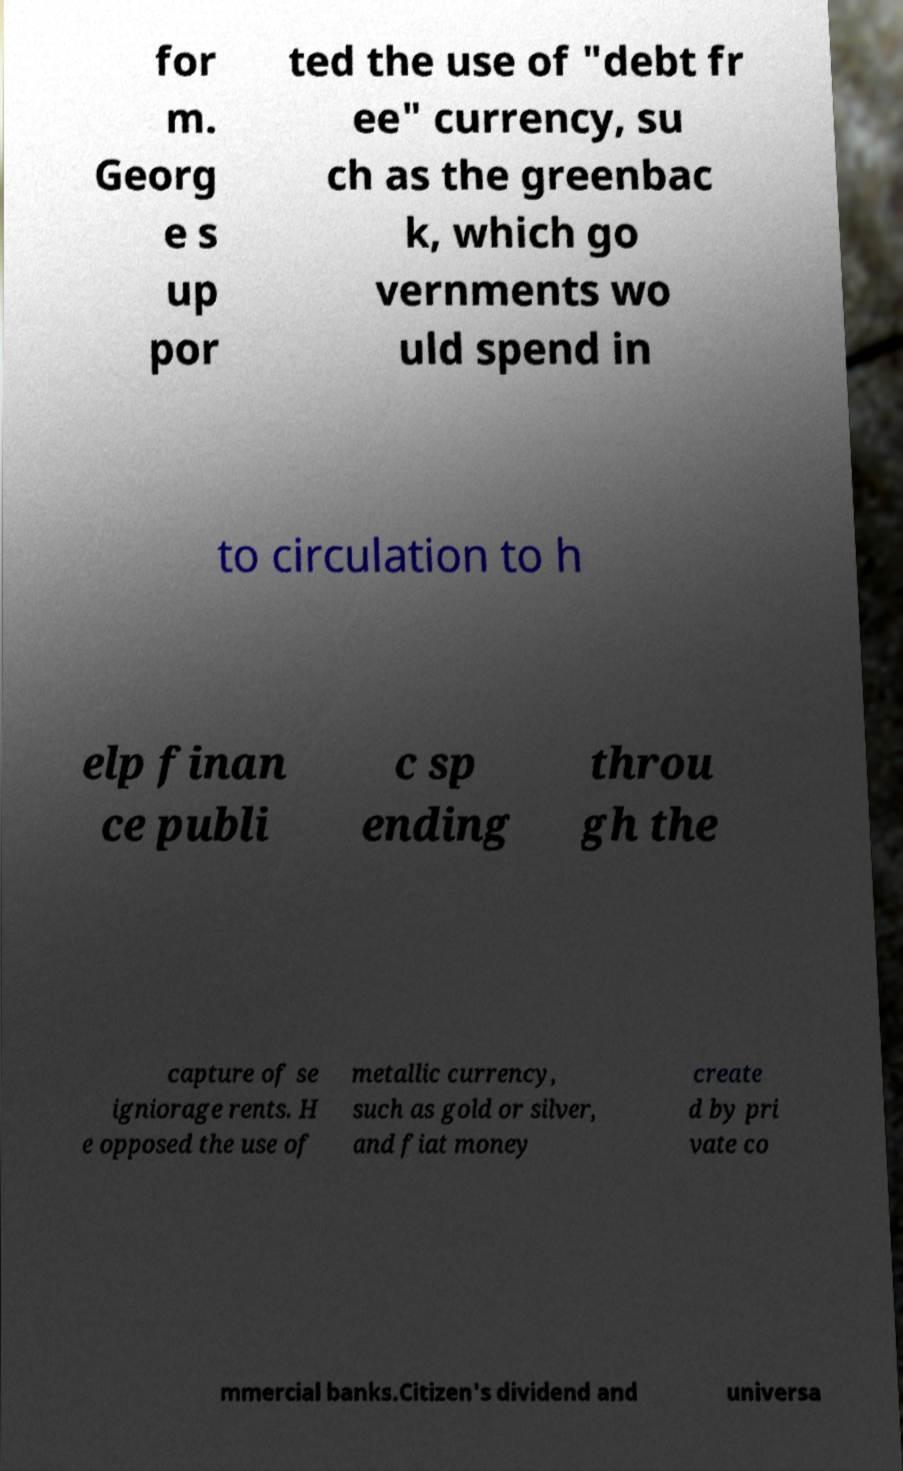There's text embedded in this image that I need extracted. Can you transcribe it verbatim? for m. Georg e s up por ted the use of "debt fr ee" currency, su ch as the greenbac k, which go vernments wo uld spend in to circulation to h elp finan ce publi c sp ending throu gh the capture of se igniorage rents. H e opposed the use of metallic currency, such as gold or silver, and fiat money create d by pri vate co mmercial banks.Citizen's dividend and universa 